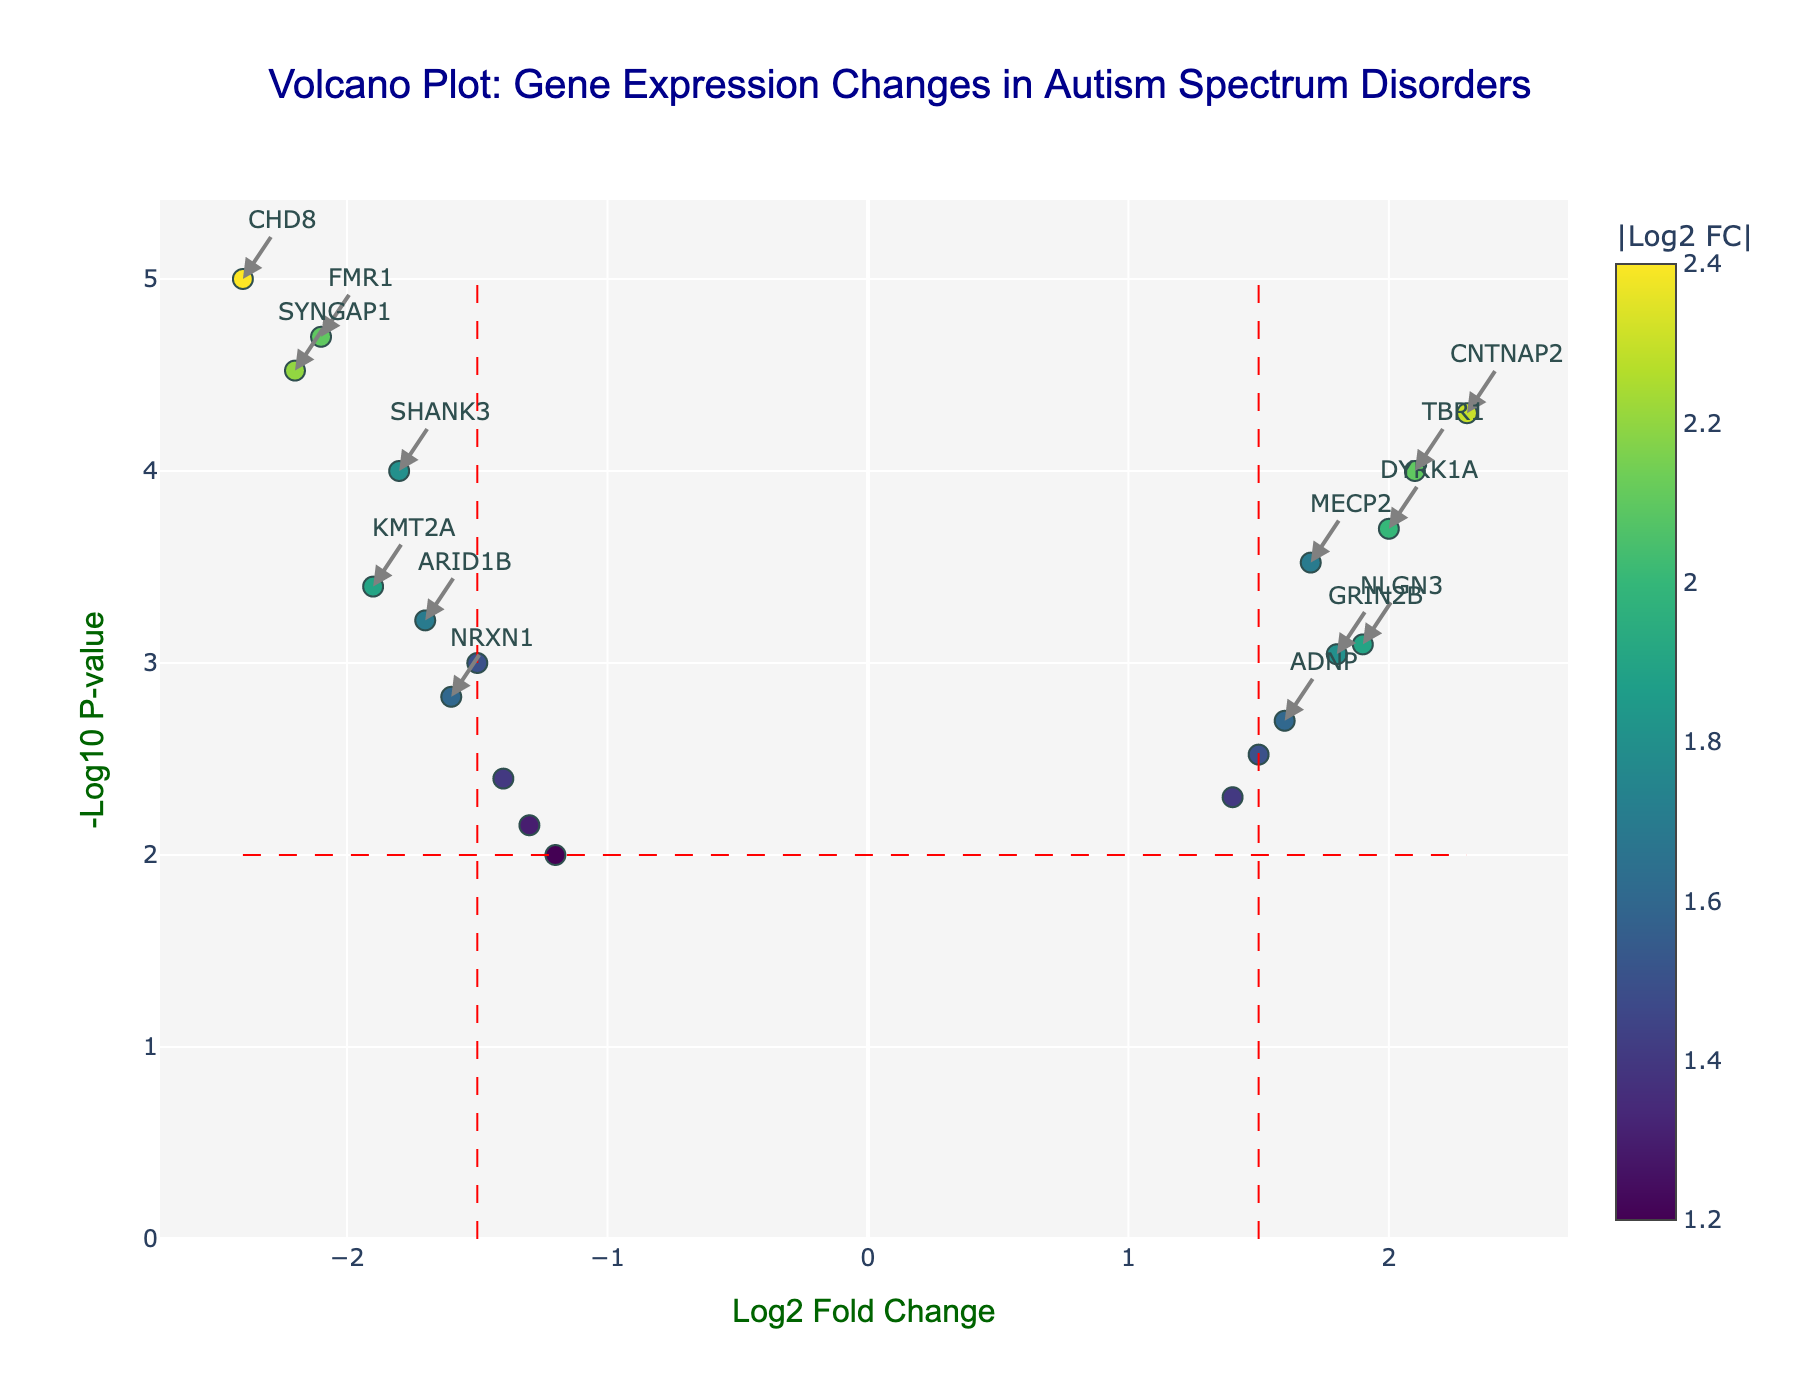How many genes are annotated as significant in the plot? Look for the genes that have annotations (text labels) on the plot. These indicate significant genes.
Answer: 10 What is the title of the plot? Read the text at the top center of the plot.
Answer: Volcano Plot: Gene Expression Changes in Autism Spectrum Disorders Which gene has the highest negative Log2 Fold Change value? Identify the gene that is furthest to the left on the x-axis.
Answer: CHD8 What are the x-axis and y-axis titles? Read the titles displayed on the x-axis and y-axis of the plot.
Answer: x-axis: Log2 Fold Change, y-axis: -Log10 P-value Which gene is associated with the lowest p-value? This gene will have the highest -Log10 P-value on the y-axis.
Answer: CHD8 Which genes have a Log2 Fold Change greater than 1.5 and a p-value less than 0.01? Find the points located to the right of the vertical line at Log2 Fold Change = 1.5 and above the horizontal line at -Log10 P-value corresponding to p-value = 0.01.
Answer: CNTNAP2, MECP2, DYRK1A, TBR1 Compare the Log2 Fold Change and -Log10 P-value of FMR1 and SYNGAP1. Which gene has a greater Fold Change and which has a smaller p-value? Check the x and y coordinates of FMR1 and SYNGAP1.
Answer: FMR1 has a greater Fold Change, SYNGAP1 has a smaller p-value How is the significance threshold represented on the plot? Look for visual elements that represent thresholds, typically lines on the plot.
Answer: Red dashed lines 